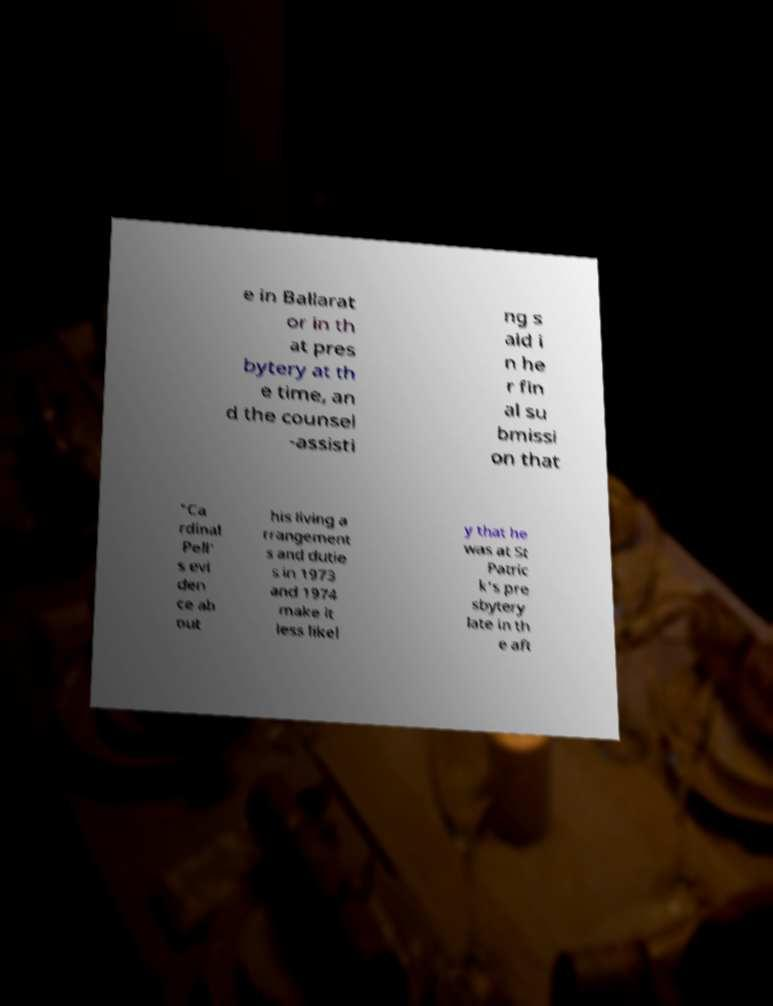There's text embedded in this image that I need extracted. Can you transcribe it verbatim? e in Ballarat or in th at pres bytery at th e time, an d the counsel -assisti ng s aid i n he r fin al su bmissi on that "Ca rdinal Pell' s evi den ce ab out his living a rrangement s and dutie s in 1973 and 1974 make it less likel y that he was at St Patric k's pre sbytery late in th e aft 